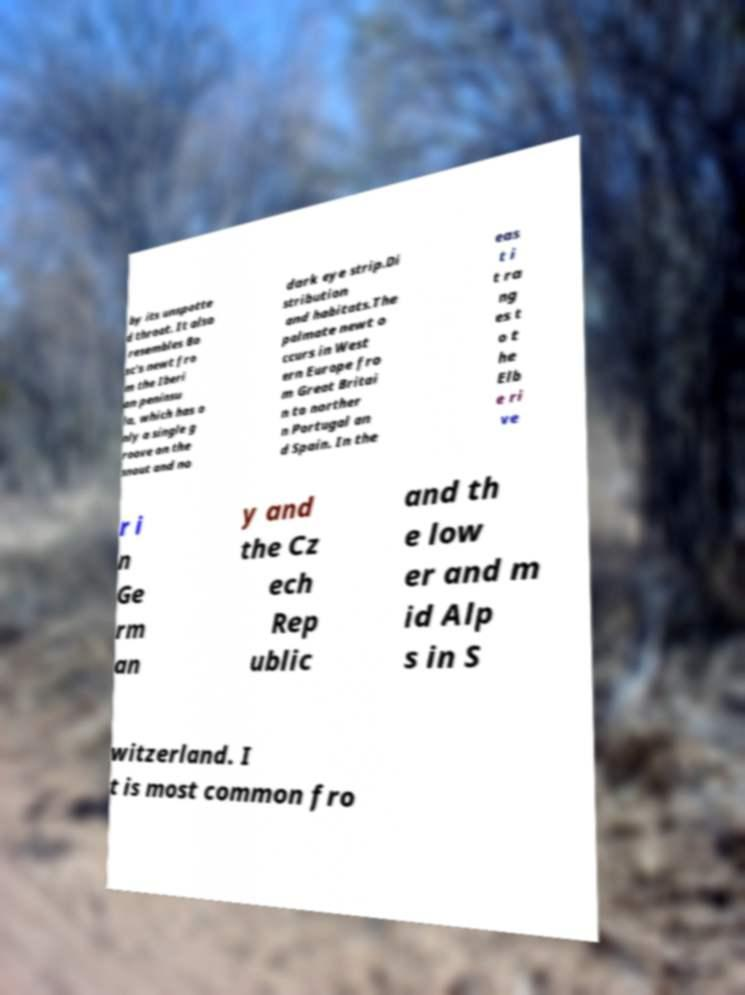I need the written content from this picture converted into text. Can you do that? by its unspotte d throat. It also resembles Bo sc's newt fro m the Iberi an peninsu la, which has o nly a single g roove on the snout and no dark eye strip.Di stribution and habitats.The palmate newt o ccurs in West ern Europe fro m Great Britai n to norther n Portugal an d Spain. In the eas t i t ra ng es t o t he Elb e ri ve r i n Ge rm an y and the Cz ech Rep ublic and th e low er and m id Alp s in S witzerland. I t is most common fro 